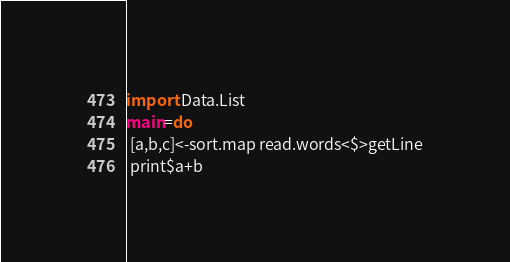Convert code to text. <code><loc_0><loc_0><loc_500><loc_500><_Haskell_>import Data.List
main=do
 [a,b,c]<-sort.map read.words<$>getLine
 print$a+b</code> 